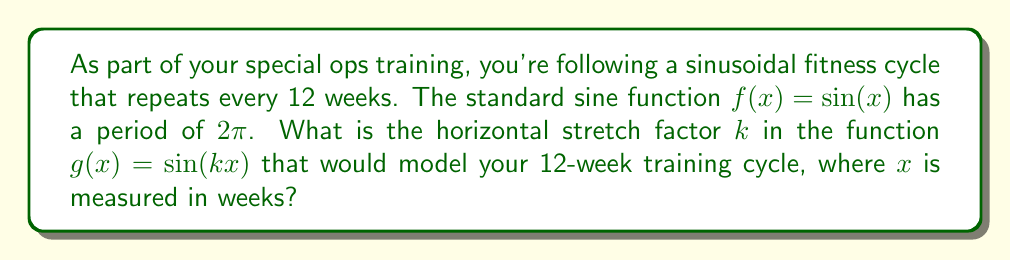Can you solve this math problem? Let's approach this step-by-step:

1) The standard sine function $f(x) = \sin(x)$ has a period of $2\pi$.

2) We want to stretch this function horizontally so that its period becomes 12 weeks.

3) For a function $g(x) = \sin(kx)$, the period is given by $\frac{2\pi}{|k|}$.

4) We can set up the equation:

   $$\frac{2\pi}{|k|} = 12$$

5) Solving for $k$:
   
   $$|k| = \frac{2\pi}{12} = \frac{\pi}{6}$$

6) Since we're stretching the function (making the period longer), $k$ will be positive.

7) Therefore, $k = \frac{\pi}{6}$.
Answer: $\frac{\pi}{6}$ 